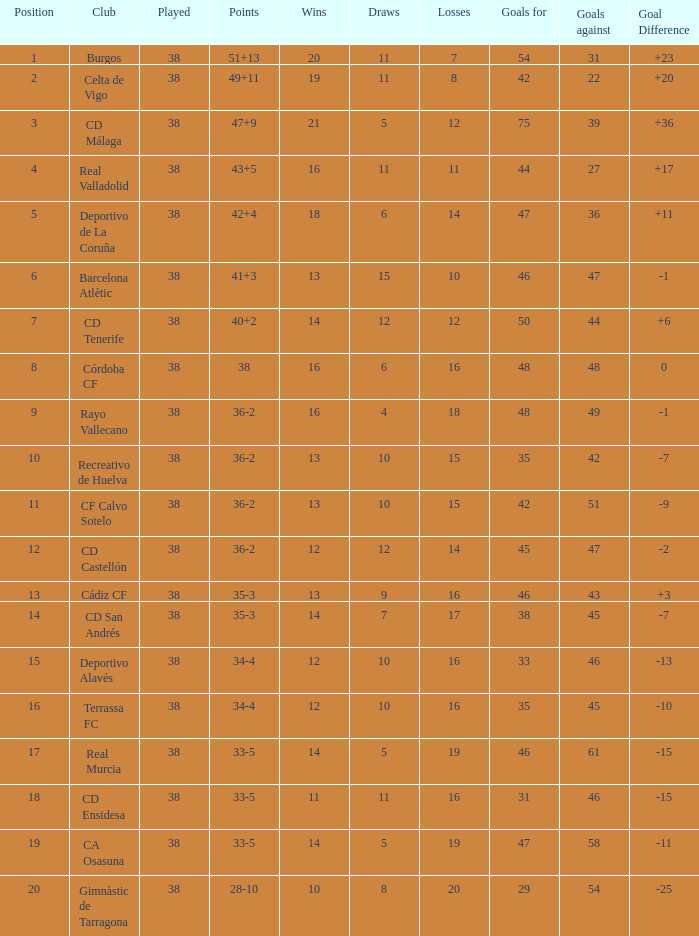Which is the least played with 28-10 points and goals greater than 29? None. 